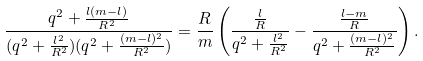<formula> <loc_0><loc_0><loc_500><loc_500>\frac { { q ^ { 2 } + \frac { l ( m - l ) } { R ^ { 2 } } } } { { ( q ^ { 2 } + \frac { l ^ { 2 } } { R ^ { 2 } } ) ( q ^ { 2 } + \frac { ( m - l ) ^ { 2 } } { R ^ { 2 } } ) } } = \frac { R } { m } \left ( \frac { \frac { l } { R } } { { q ^ { 2 } + \frac { l ^ { 2 } } { R ^ { 2 } } } } - \frac { \frac { l - m } { R } } { { q ^ { 2 } + \frac { ( m - l ) ^ { 2 } } { R ^ { 2 } } } } \right ) .</formula> 